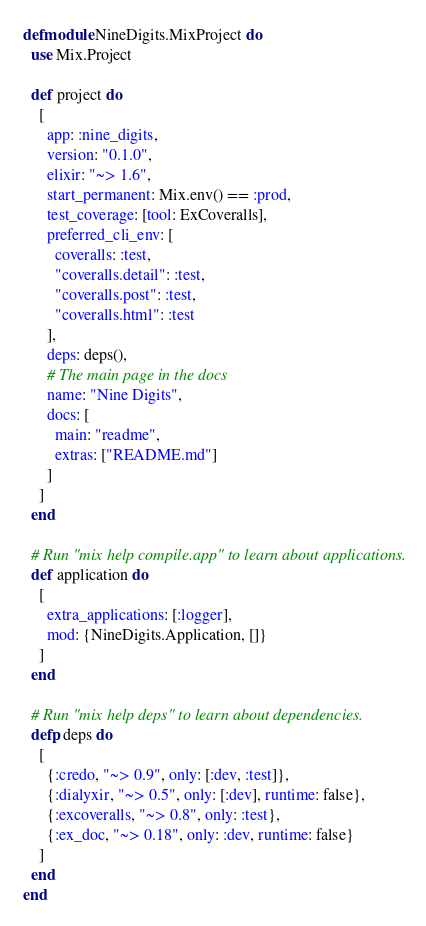<code> <loc_0><loc_0><loc_500><loc_500><_Elixir_>defmodule NineDigits.MixProject do
  use Mix.Project

  def project do
    [
      app: :nine_digits,
      version: "0.1.0",
      elixir: "~> 1.6",
      start_permanent: Mix.env() == :prod,
      test_coverage: [tool: ExCoveralls],
      preferred_cli_env: [
        coveralls: :test,
        "coveralls.detail": :test,
        "coveralls.post": :test,
        "coveralls.html": :test
      ],
      deps: deps(),
      # The main page in the docs
      name: "Nine Digits",
      docs: [
        main: "readme",
        extras: ["README.md"]
      ]
    ]
  end

  # Run "mix help compile.app" to learn about applications.
  def application do
    [
      extra_applications: [:logger],
      mod: {NineDigits.Application, []}
    ]
  end

  # Run "mix help deps" to learn about dependencies.
  defp deps do
    [
      {:credo, "~> 0.9", only: [:dev, :test]},
      {:dialyxir, "~> 0.5", only: [:dev], runtime: false},
      {:excoveralls, "~> 0.8", only: :test},
      {:ex_doc, "~> 0.18", only: :dev, runtime: false}
    ]
  end
end
</code> 